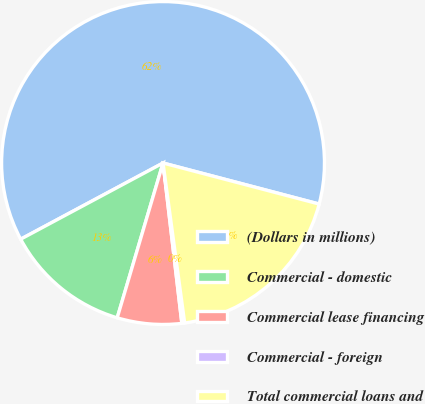Convert chart to OTSL. <chart><loc_0><loc_0><loc_500><loc_500><pie_chart><fcel>(Dollars in millions)<fcel>Commercial - domestic<fcel>Commercial lease financing<fcel>Commercial - foreign<fcel>Total commercial loans and<nl><fcel>61.91%<fcel>12.6%<fcel>6.44%<fcel>0.28%<fcel>18.77%<nl></chart> 